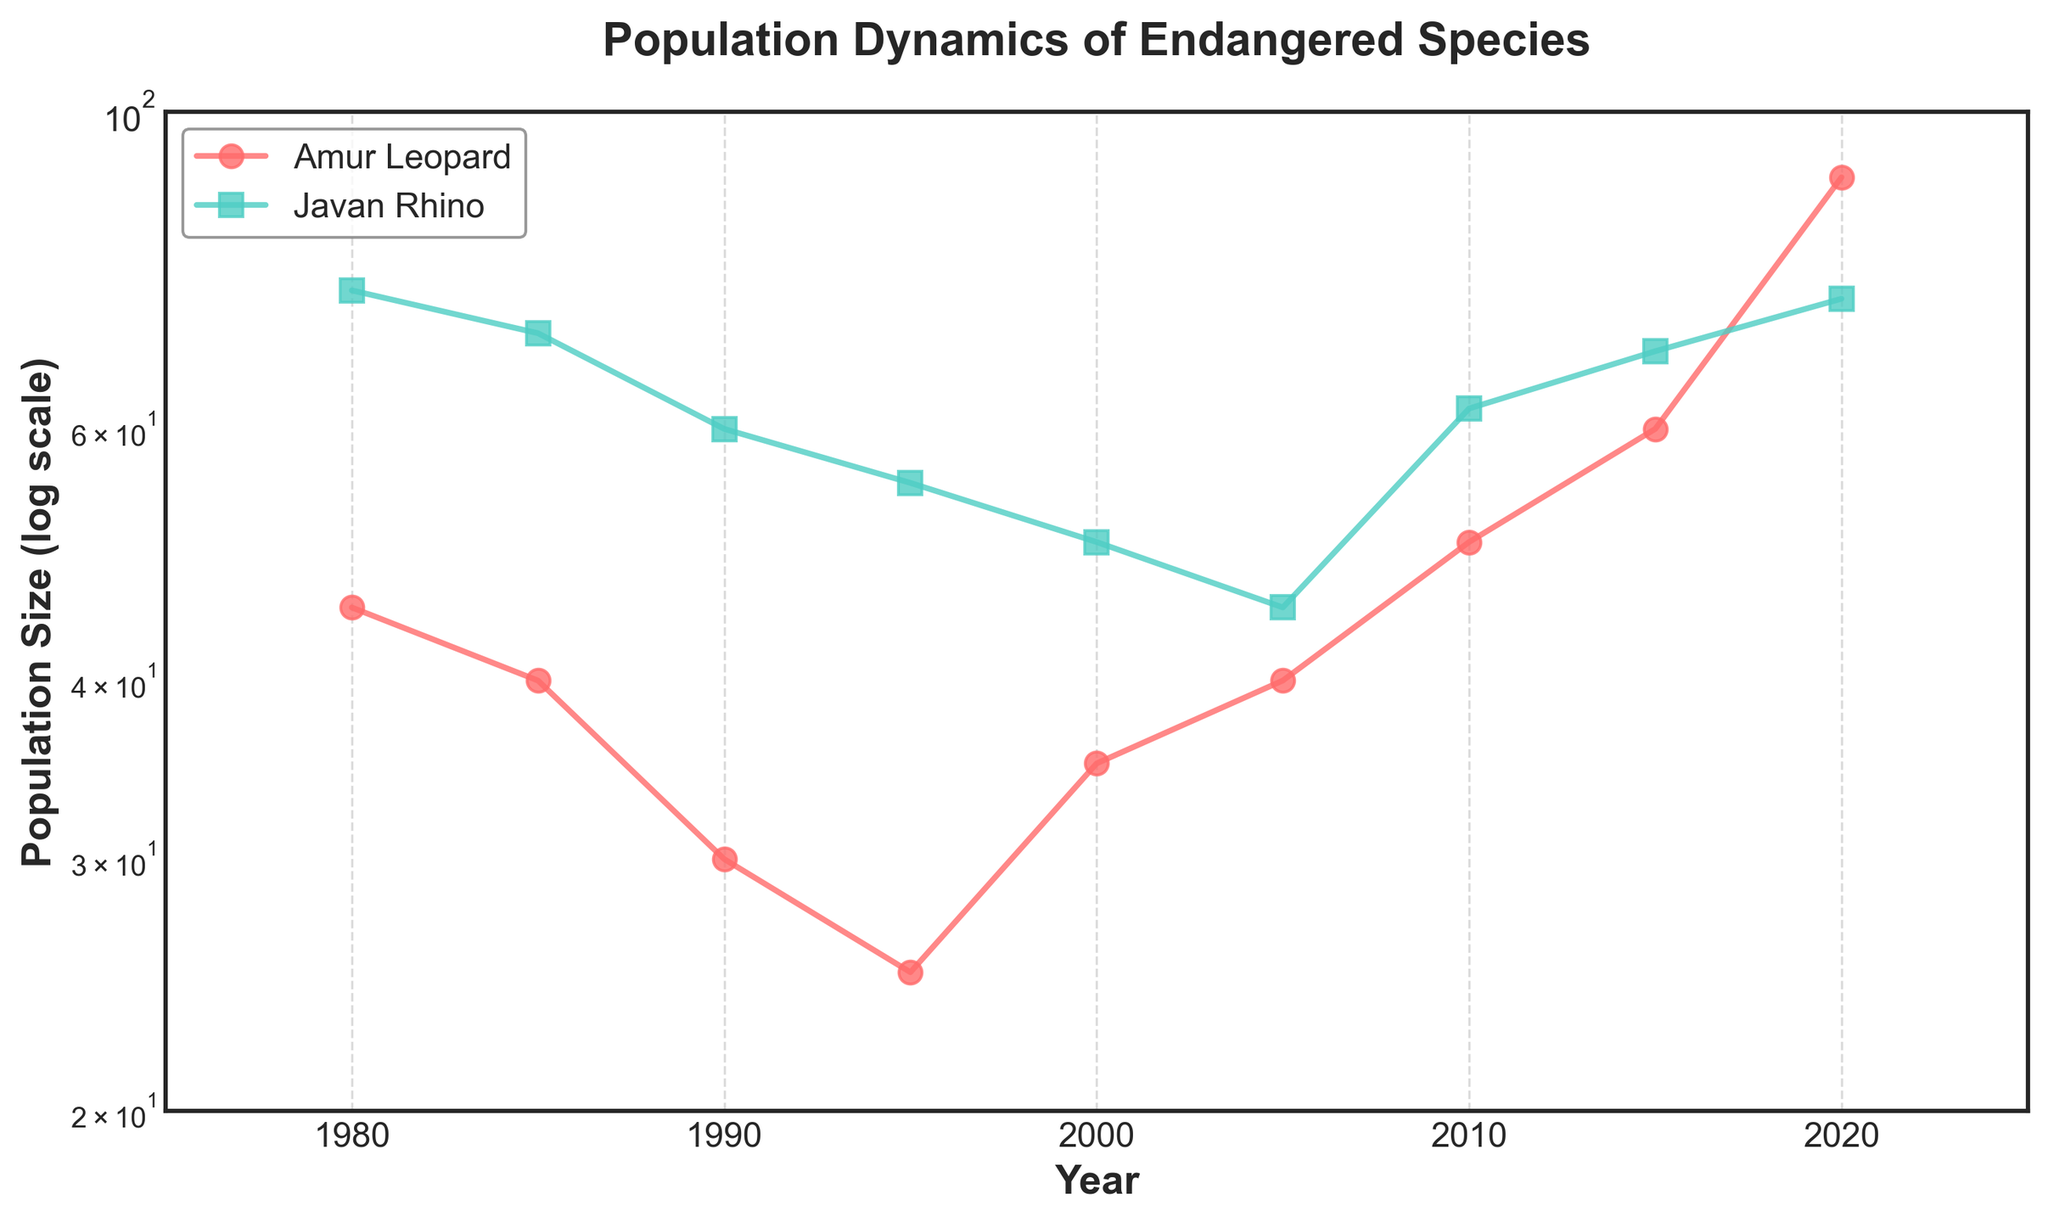What is the title of the plot? The title is usually located at the top of the plot. In this case, it reads "Population Dynamics of Endangered Species".
Answer: Population Dynamics of Endangered Species What are the two species being compared in this plot? The species labels are present in the legend on the plot, which usually indicates what each line represents. Here, the species are the Amur Leopard and the Javan Rhino.
Answer: Amur Leopard, Javan Rhino What is the range of years shown on the x-axis? The x-axis runs from the beginning to the end range of the displayed years. Here, it starts at 1975 and ends at 2025.
Answer: 1975, 2025 Which species had a higher population in the year 2000? By following the year 2000 on the x-axis and comparing the y-values of both lines, the Amur Leopard had a population size of 35, while the Javan Rhino had a population size of 50.
Answer: Javan Rhino What is the population size of the Amur Leopard in 2015? Locate 2015 on the x-axis, then find the corresponding y-value on the Amur Leopard's line, which is marked with a circular marker. The population size at this point is 60.
Answer: 60 By what factor did the Amur Leopard population increase from 1995 to 2020? From 1995, the population size for Amur Leopards was 25. In 2020, it was 90. Dividing 90 by 25 gives a factor of 3.6.
Answer: 3.6 Which species showed a continuous population decline from 1980 to 2005? Following the lines for each species from 1980 to 2005, both lines reduce in population size, but the Javan Rhino shows a continuous decline from 75 to 45 without any increase.
Answer: Javan Rhino In what year did the Javan Rhino population start to increase again after continuous decline? Tracing the Javan Rhino's population line from left to right, the population decreases until 2005, where it reaches its minimum at 45, and then it starts to increase.
Answer: 2005 How does the y-axis display population size, and why might this be useful? The y-axis utilizes a logarithmic scale, as indicated by its label. This allows for more manageable representation and comparison of a wide range of population sizes.
Answer: Logarithmic scale; better comparison What was the population size difference between the two species in 2010? In 2010, the Amur Leopard had a population size of 50, whereas the Javan Rhino had 62. The difference is \( 62 - 50 = 12 \).
Answer: 12 